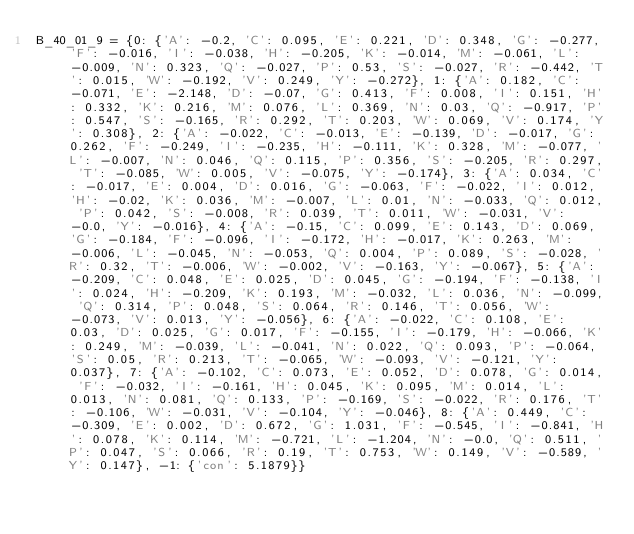<code> <loc_0><loc_0><loc_500><loc_500><_Python_>B_40_01_9 = {0: {'A': -0.2, 'C': 0.095, 'E': 0.221, 'D': 0.348, 'G': -0.277, 'F': -0.016, 'I': -0.038, 'H': -0.205, 'K': -0.014, 'M': -0.061, 'L': -0.009, 'N': 0.323, 'Q': -0.027, 'P': 0.53, 'S': -0.027, 'R': -0.442, 'T': 0.015, 'W': -0.192, 'V': 0.249, 'Y': -0.272}, 1: {'A': 0.182, 'C': -0.071, 'E': -2.148, 'D': -0.07, 'G': 0.413, 'F': 0.008, 'I': 0.151, 'H': 0.332, 'K': 0.216, 'M': 0.076, 'L': 0.369, 'N': 0.03, 'Q': -0.917, 'P': 0.547, 'S': -0.165, 'R': 0.292, 'T': 0.203, 'W': 0.069, 'V': 0.174, 'Y': 0.308}, 2: {'A': -0.022, 'C': -0.013, 'E': -0.139, 'D': -0.017, 'G': 0.262, 'F': -0.249, 'I': -0.235, 'H': -0.111, 'K': 0.328, 'M': -0.077, 'L': -0.007, 'N': 0.046, 'Q': 0.115, 'P': 0.356, 'S': -0.205, 'R': 0.297, 'T': -0.085, 'W': 0.005, 'V': -0.075, 'Y': -0.174}, 3: {'A': 0.034, 'C': -0.017, 'E': 0.004, 'D': 0.016, 'G': -0.063, 'F': -0.022, 'I': 0.012, 'H': -0.02, 'K': 0.036, 'M': -0.007, 'L': 0.01, 'N': -0.033, 'Q': 0.012, 'P': 0.042, 'S': -0.008, 'R': 0.039, 'T': 0.011, 'W': -0.031, 'V': -0.0, 'Y': -0.016}, 4: {'A': -0.15, 'C': 0.099, 'E': 0.143, 'D': 0.069, 'G': -0.184, 'F': -0.096, 'I': -0.172, 'H': -0.017, 'K': 0.263, 'M': -0.006, 'L': -0.045, 'N': -0.053, 'Q': 0.004, 'P': 0.089, 'S': -0.028, 'R': 0.32, 'T': -0.006, 'W': -0.002, 'V': -0.163, 'Y': -0.067}, 5: {'A': -0.209, 'C': 0.048, 'E': 0.025, 'D': 0.045, 'G': -0.194, 'F': -0.138, 'I': 0.024, 'H': -0.209, 'K': 0.193, 'M': -0.032, 'L': 0.036, 'N': -0.099, 'Q': 0.314, 'P': 0.048, 'S': 0.064, 'R': 0.146, 'T': 0.056, 'W': -0.073, 'V': 0.013, 'Y': -0.056}, 6: {'A': -0.022, 'C': 0.108, 'E': 0.03, 'D': 0.025, 'G': 0.017, 'F': -0.155, 'I': -0.179, 'H': -0.066, 'K': 0.249, 'M': -0.039, 'L': -0.041, 'N': 0.022, 'Q': 0.093, 'P': -0.064, 'S': 0.05, 'R': 0.213, 'T': -0.065, 'W': -0.093, 'V': -0.121, 'Y': 0.037}, 7: {'A': -0.102, 'C': 0.073, 'E': 0.052, 'D': 0.078, 'G': 0.014, 'F': -0.032, 'I': -0.161, 'H': 0.045, 'K': 0.095, 'M': 0.014, 'L': 0.013, 'N': 0.081, 'Q': 0.133, 'P': -0.169, 'S': -0.022, 'R': 0.176, 'T': -0.106, 'W': -0.031, 'V': -0.104, 'Y': -0.046}, 8: {'A': 0.449, 'C': -0.309, 'E': 0.002, 'D': 0.672, 'G': 1.031, 'F': -0.545, 'I': -0.841, 'H': 0.078, 'K': 0.114, 'M': -0.721, 'L': -1.204, 'N': -0.0, 'Q': 0.511, 'P': 0.047, 'S': 0.066, 'R': 0.19, 'T': 0.753, 'W': 0.149, 'V': -0.589, 'Y': 0.147}, -1: {'con': 5.1879}}</code> 